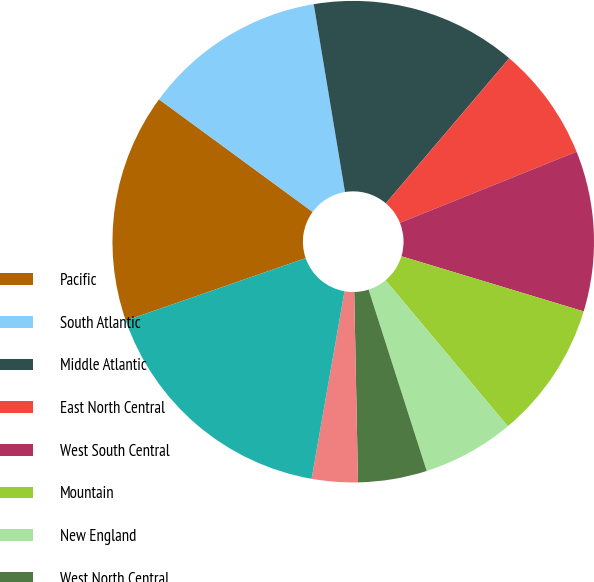Convert chart to OTSL. <chart><loc_0><loc_0><loc_500><loc_500><pie_chart><fcel>Pacific<fcel>South Atlantic<fcel>Middle Atlantic<fcel>East North Central<fcel>West South Central<fcel>Mountain<fcel>New England<fcel>West North Central<fcel>East South Central<fcel>Subtotal-US<nl><fcel>15.38%<fcel>12.31%<fcel>13.84%<fcel>7.69%<fcel>10.77%<fcel>9.23%<fcel>6.16%<fcel>4.62%<fcel>3.08%<fcel>16.92%<nl></chart> 